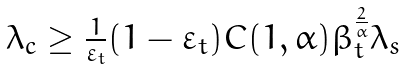<formula> <loc_0><loc_0><loc_500><loc_500>\begin{array} { l l } \lambda _ { c } \geq \frac { 1 } { \varepsilon _ { t } } ( 1 - \varepsilon _ { t } ) C ( 1 , \alpha ) \beta _ { t } ^ { \frac { 2 } { \alpha } } \lambda _ { s } \end{array}</formula> 